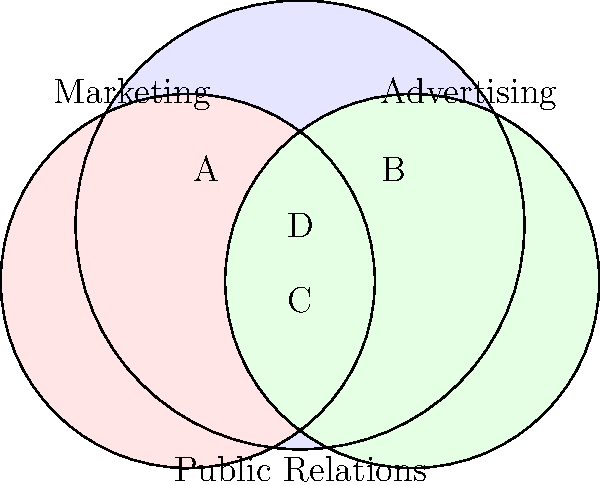In the Venn diagram above, which area represents activities that involve all three disciplines: marketing, advertising, and public relations? To answer this question, we need to understand the components of the Venn diagram:

1. The blue circle represents Marketing.
2. The red circle represents Advertising.
3. The green circle represents Public Relations.

The area where all three circles overlap is the region that represents activities involving all three disciplines. This is because:

1. Activities in this area are within the Marketing circle, so they involve marketing.
2. They are also within the Advertising circle, so they involve advertising.
3. Finally, they are within the Public Relations circle, so they involve public relations.

In the diagram, this area of triple overlap is labeled with the letter "D". This central region represents the intersection of all three disciplines, where activities or strategies would incorporate elements of marketing, advertising, and public relations simultaneously.

Examples of activities in this area might include:
- Integrated marketing communications campaigns
- Brand storytelling across multiple channels
- Social media influencer collaborations that blend promotional content with public image management

Understanding this overlap is crucial for a communications professional in public relations, as it highlights the interconnected nature of these fields and the potential for synergistic strategies.
Answer: D 